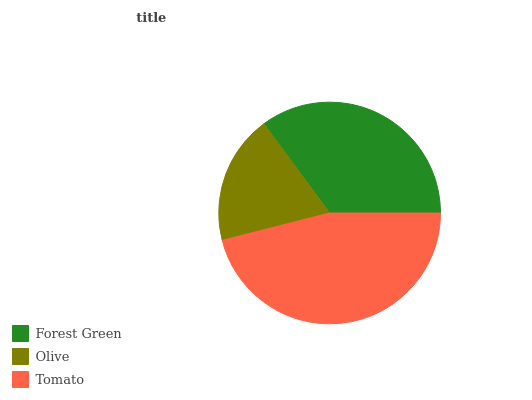Is Olive the minimum?
Answer yes or no. Yes. Is Tomato the maximum?
Answer yes or no. Yes. Is Tomato the minimum?
Answer yes or no. No. Is Olive the maximum?
Answer yes or no. No. Is Tomato greater than Olive?
Answer yes or no. Yes. Is Olive less than Tomato?
Answer yes or no. Yes. Is Olive greater than Tomato?
Answer yes or no. No. Is Tomato less than Olive?
Answer yes or no. No. Is Forest Green the high median?
Answer yes or no. Yes. Is Forest Green the low median?
Answer yes or no. Yes. Is Tomato the high median?
Answer yes or no. No. Is Tomato the low median?
Answer yes or no. No. 